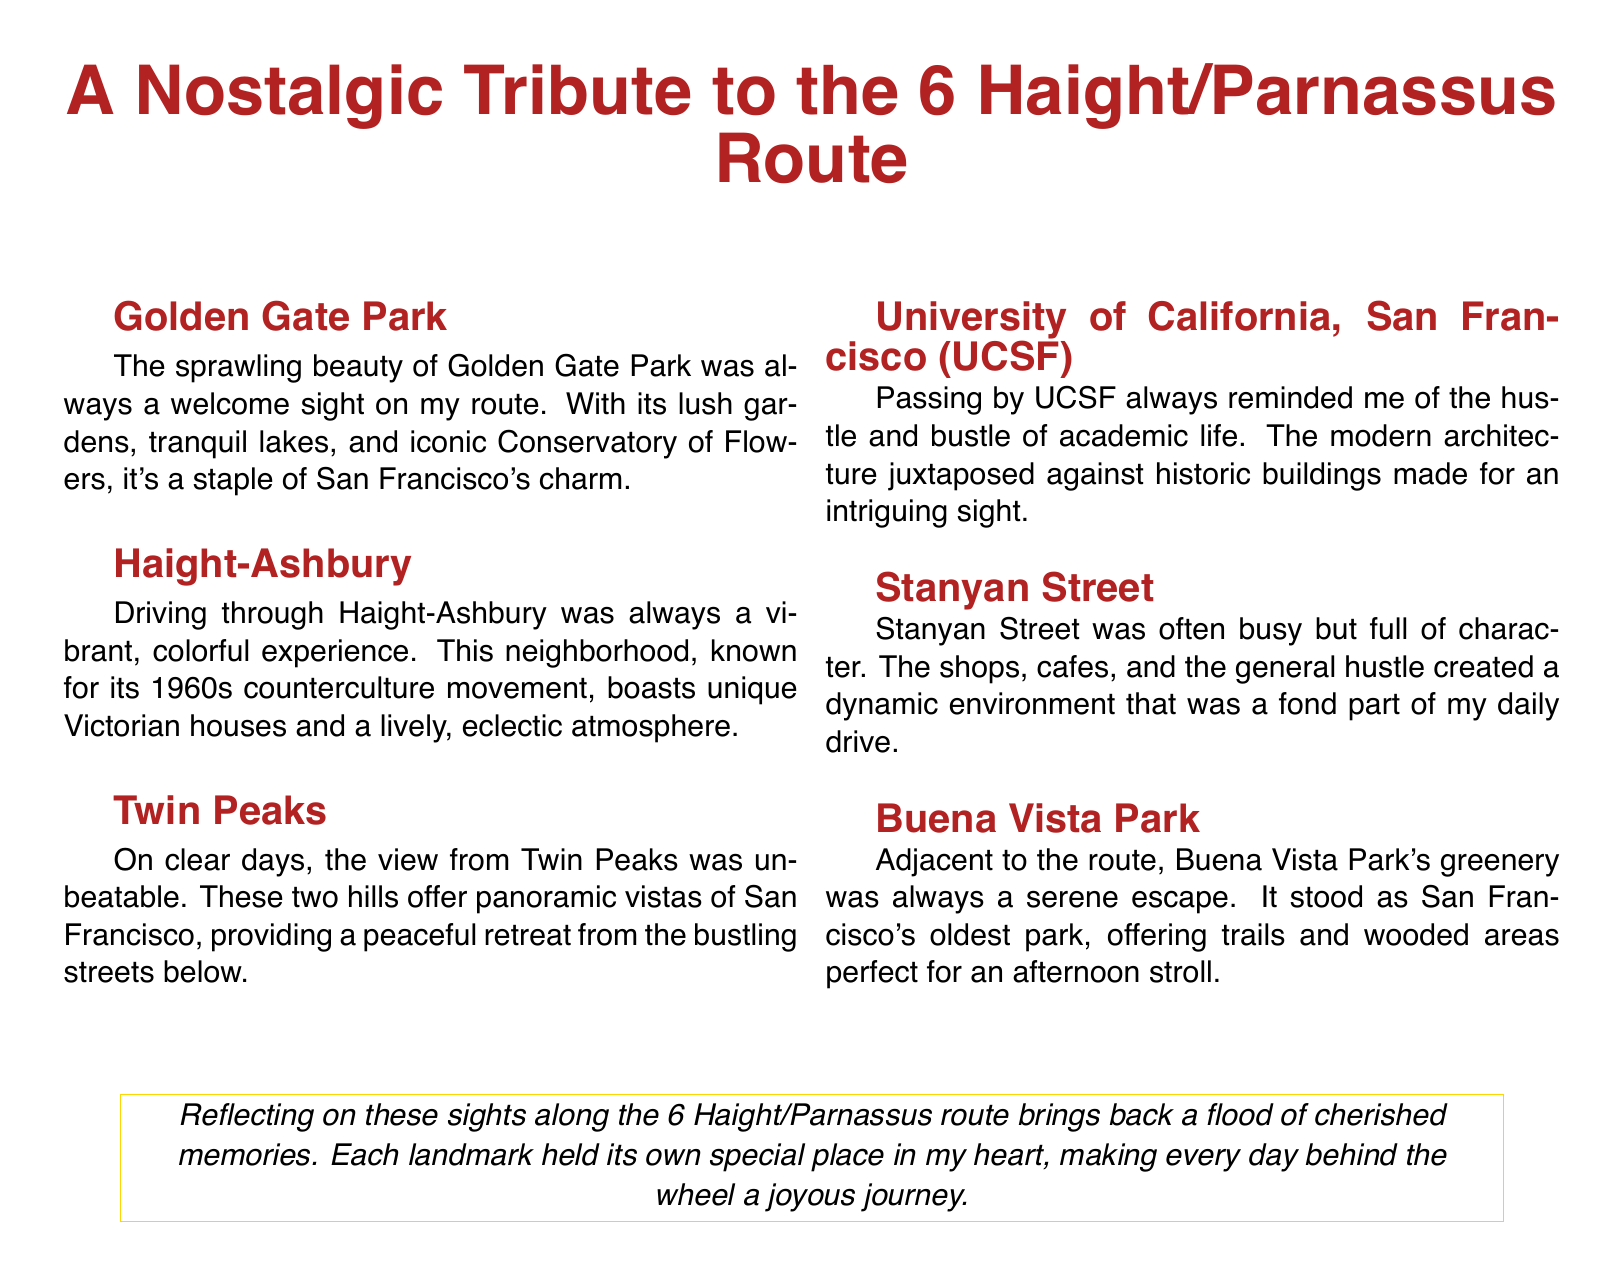What is the title of the greeting card? The title of the greeting card is the central caption at the top of the document.
Answer: A Nostalgic Tribute to the 6 Haight/Parnassus Route How many landmarks are depicted in the card? The document lists each of the landmarks associated with the 6 Haight/Parnassus route in sequential order, totaling six landmarks.
Answer: 6 Which landmark is associated with the phrase "sprawling beauty"? This phrase describes the first landmark mentioned in the document, which highlights its characteristics.
Answer: Golden Gate Park What was a vibrant experience mentioned in the document? The vibrant experience is directly tied to the description of the neighborhood known for its 1960s counterculture.
Answer: Haight-Ashbury What type of architecture is referenced in relation to UCSF? The description contrasts modern architecture with older buildings to highlight the university.
Answer: Modern architecture Which landmark is described as "the oldest park"? The document explicitly states this attribute for one of the landmarks along the route.
Answer: Buena Vista Park What does the card reflect on regarding the sights? The concluding statement summarizes the overall sentiment about the landmarks along the route.
Answer: Cherished memories In how many columns is the text organized? The section containing the landmarks is divided into multiple sections for visual presentation.
Answer: 2 What is the color of the box surrounding the reflective statement? The document indicates the specific color used for the box, contrasting with the background.
Answer: Bus yellow 